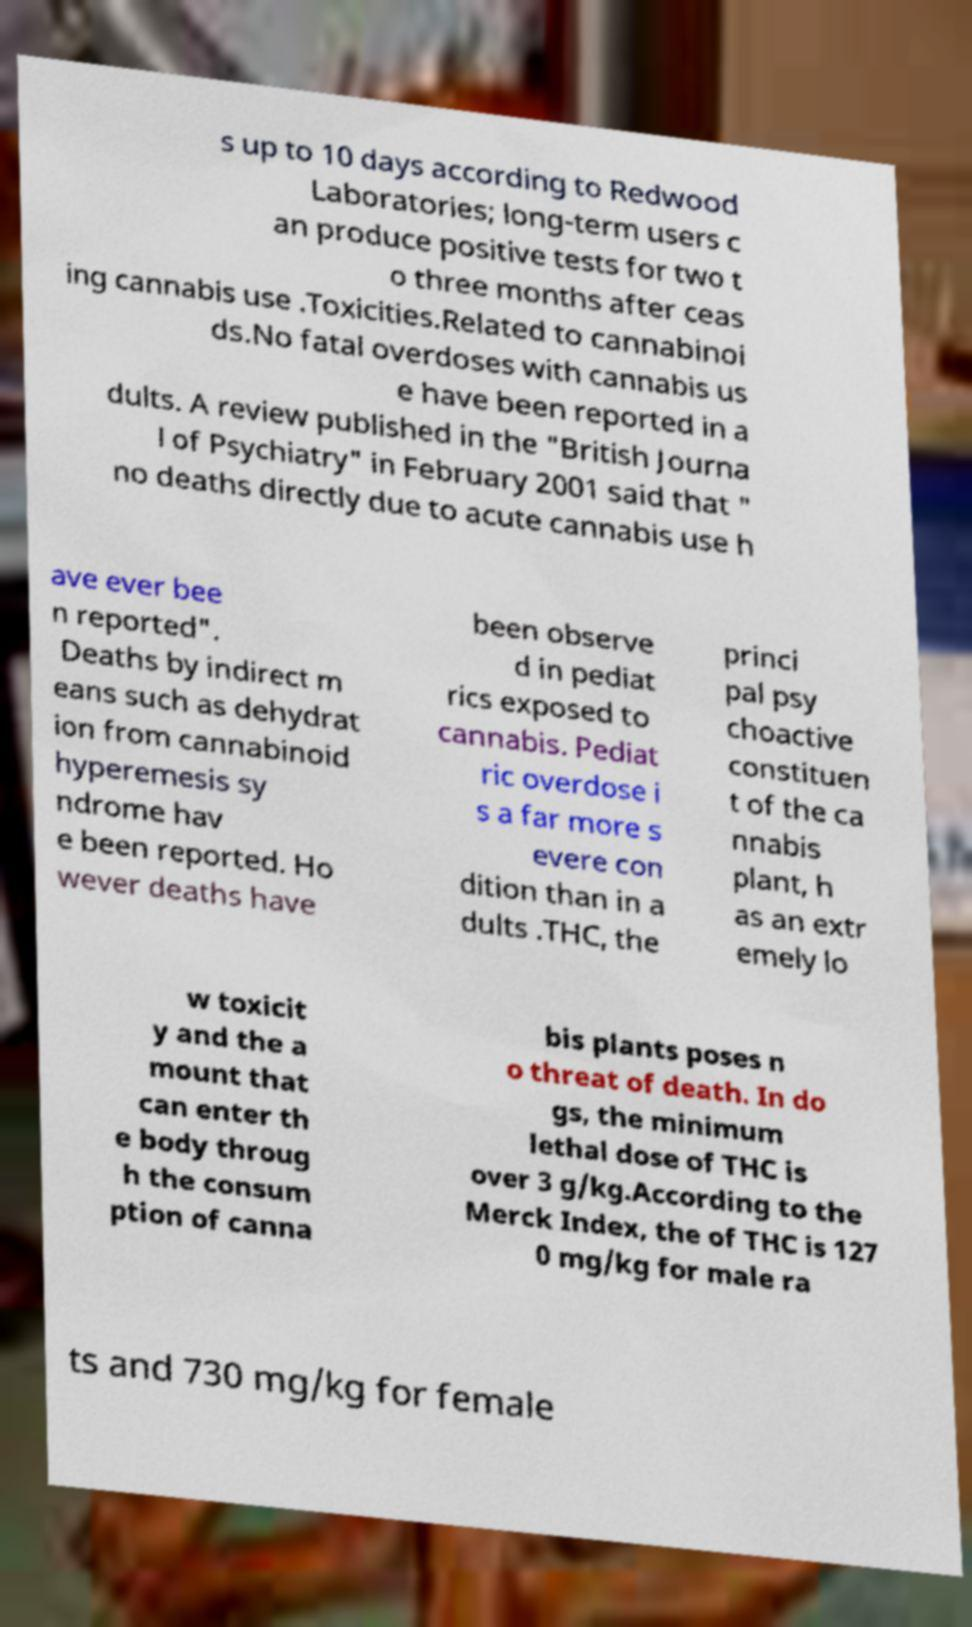Could you assist in decoding the text presented in this image and type it out clearly? s up to 10 days according to Redwood Laboratories; long-term users c an produce positive tests for two t o three months after ceas ing cannabis use .Toxicities.Related to cannabinoi ds.No fatal overdoses with cannabis us e have been reported in a dults. A review published in the "British Journa l of Psychiatry" in February 2001 said that " no deaths directly due to acute cannabis use h ave ever bee n reported". Deaths by indirect m eans such as dehydrat ion from cannabinoid hyperemesis sy ndrome hav e been reported. Ho wever deaths have been observe d in pediat rics exposed to cannabis. Pediat ric overdose i s a far more s evere con dition than in a dults .THC, the princi pal psy choactive constituen t of the ca nnabis plant, h as an extr emely lo w toxicit y and the a mount that can enter th e body throug h the consum ption of canna bis plants poses n o threat of death. In do gs, the minimum lethal dose of THC is over 3 g/kg.According to the Merck Index, the of THC is 127 0 mg/kg for male ra ts and 730 mg/kg for female 